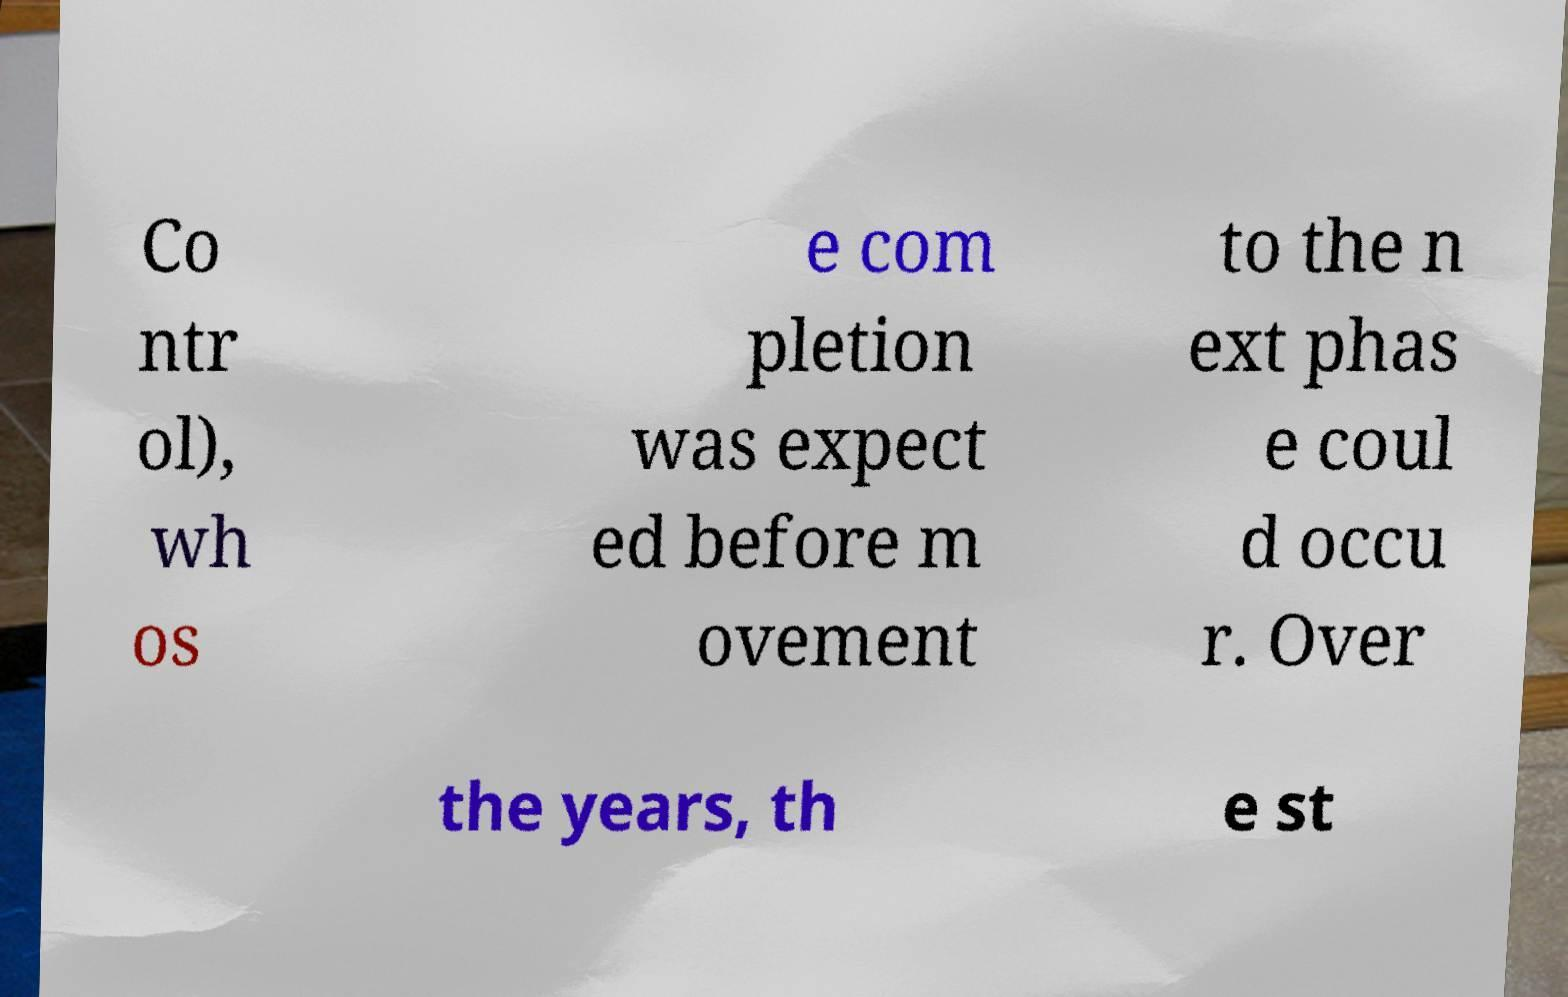Please read and relay the text visible in this image. What does it say? Co ntr ol), wh os e com pletion was expect ed before m ovement to the n ext phas e coul d occu r. Over the years, th e st 